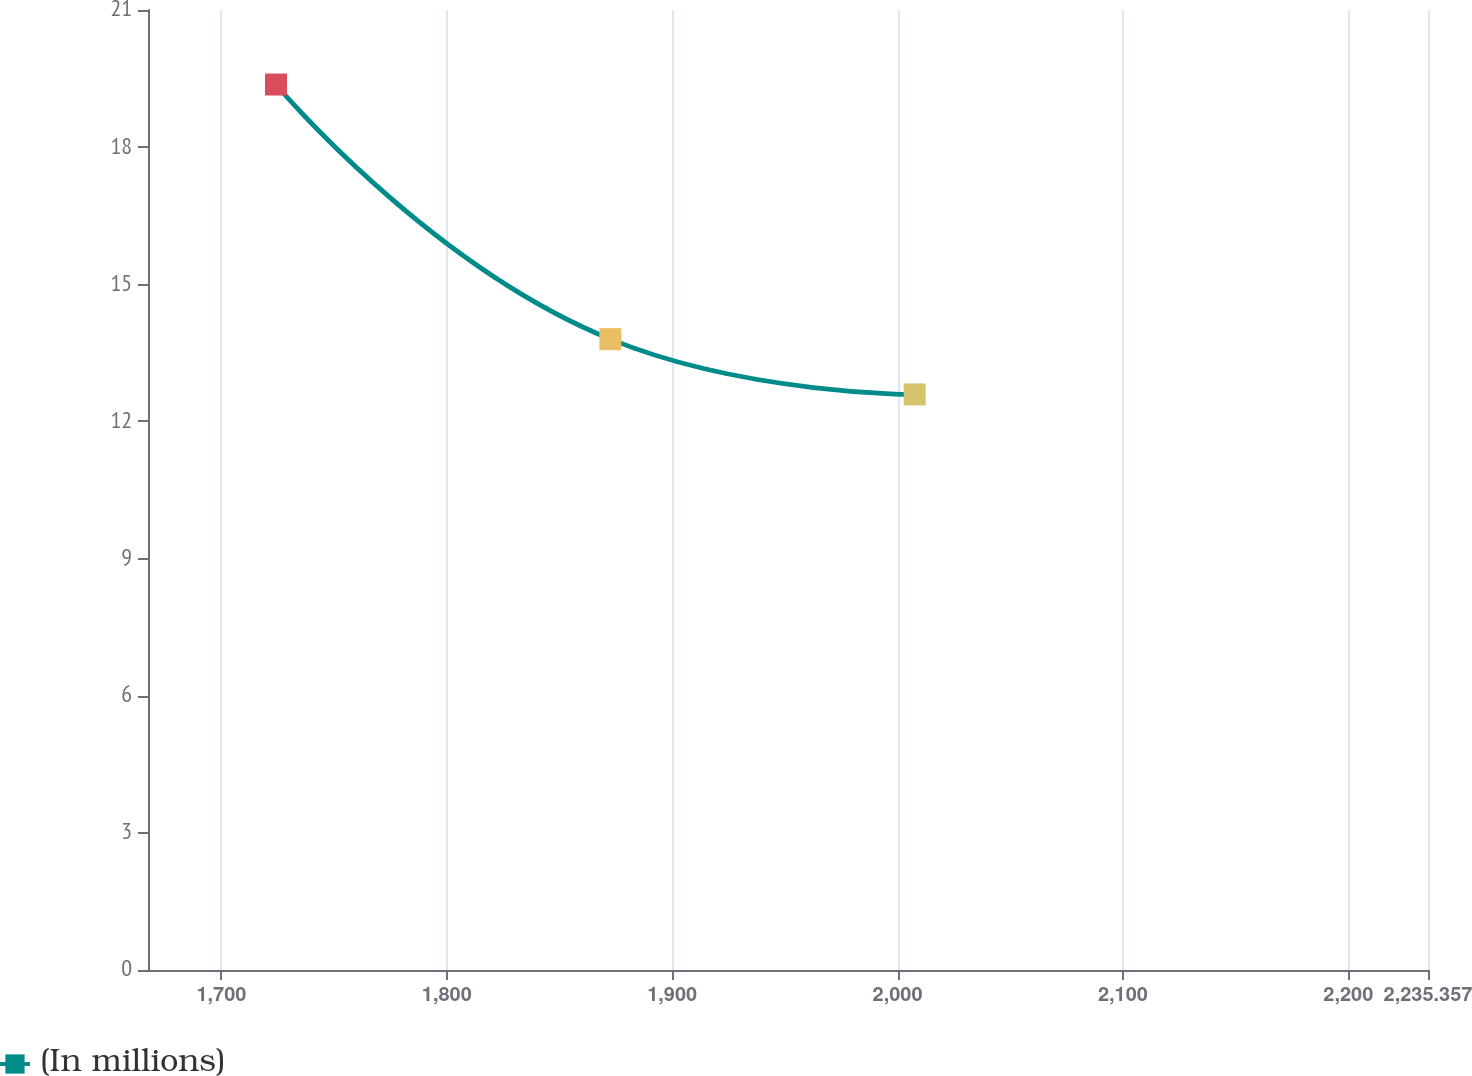Convert chart. <chart><loc_0><loc_0><loc_500><loc_500><line_chart><ecel><fcel>(In millions)<nl><fcel>1724.22<fcel>19.37<nl><fcel>1872.57<fcel>13.8<nl><fcel>2007.6<fcel>12.59<nl><fcel>2238.48<fcel>8.51<nl><fcel>2292.15<fcel>7.3<nl></chart> 